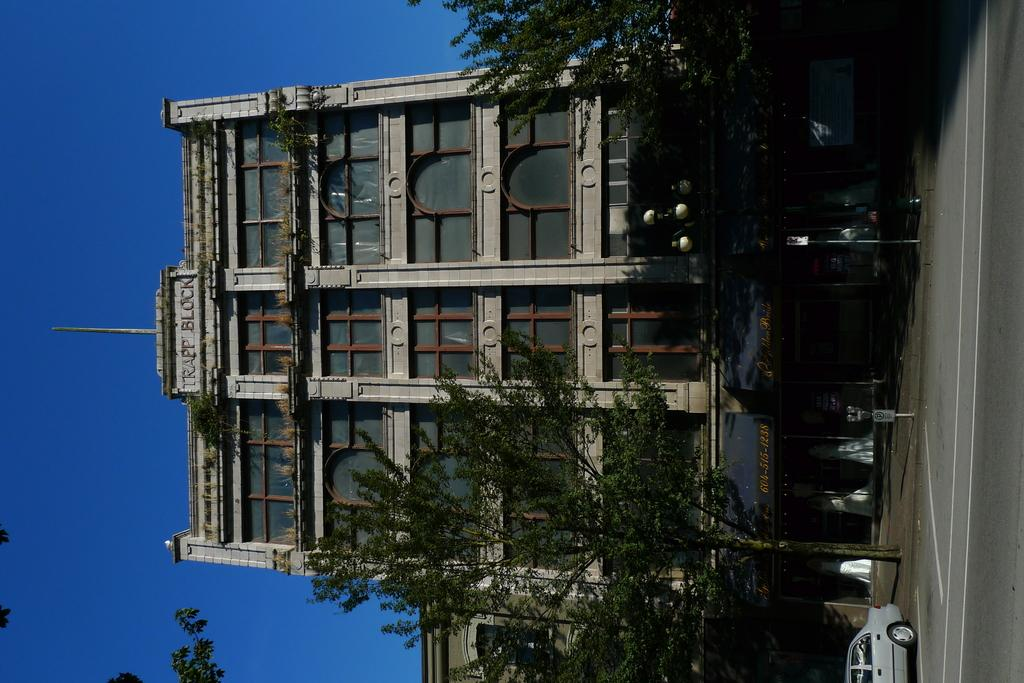What type of vehicle is on the road in the image? There is a car on the road in the image. What objects can be seen in the image besides the car? There are boards, poles, trees, and buildings in the image. What is visible in the background of the image? The sky is visible in the background of the image. What type of nut is being used to replace the light bulb in the image? There is no nut or light bulb present in the image. Is the car driving downtown in the image? The image does not specify the location as downtown, and there is no indication of the car's direction or destination. 